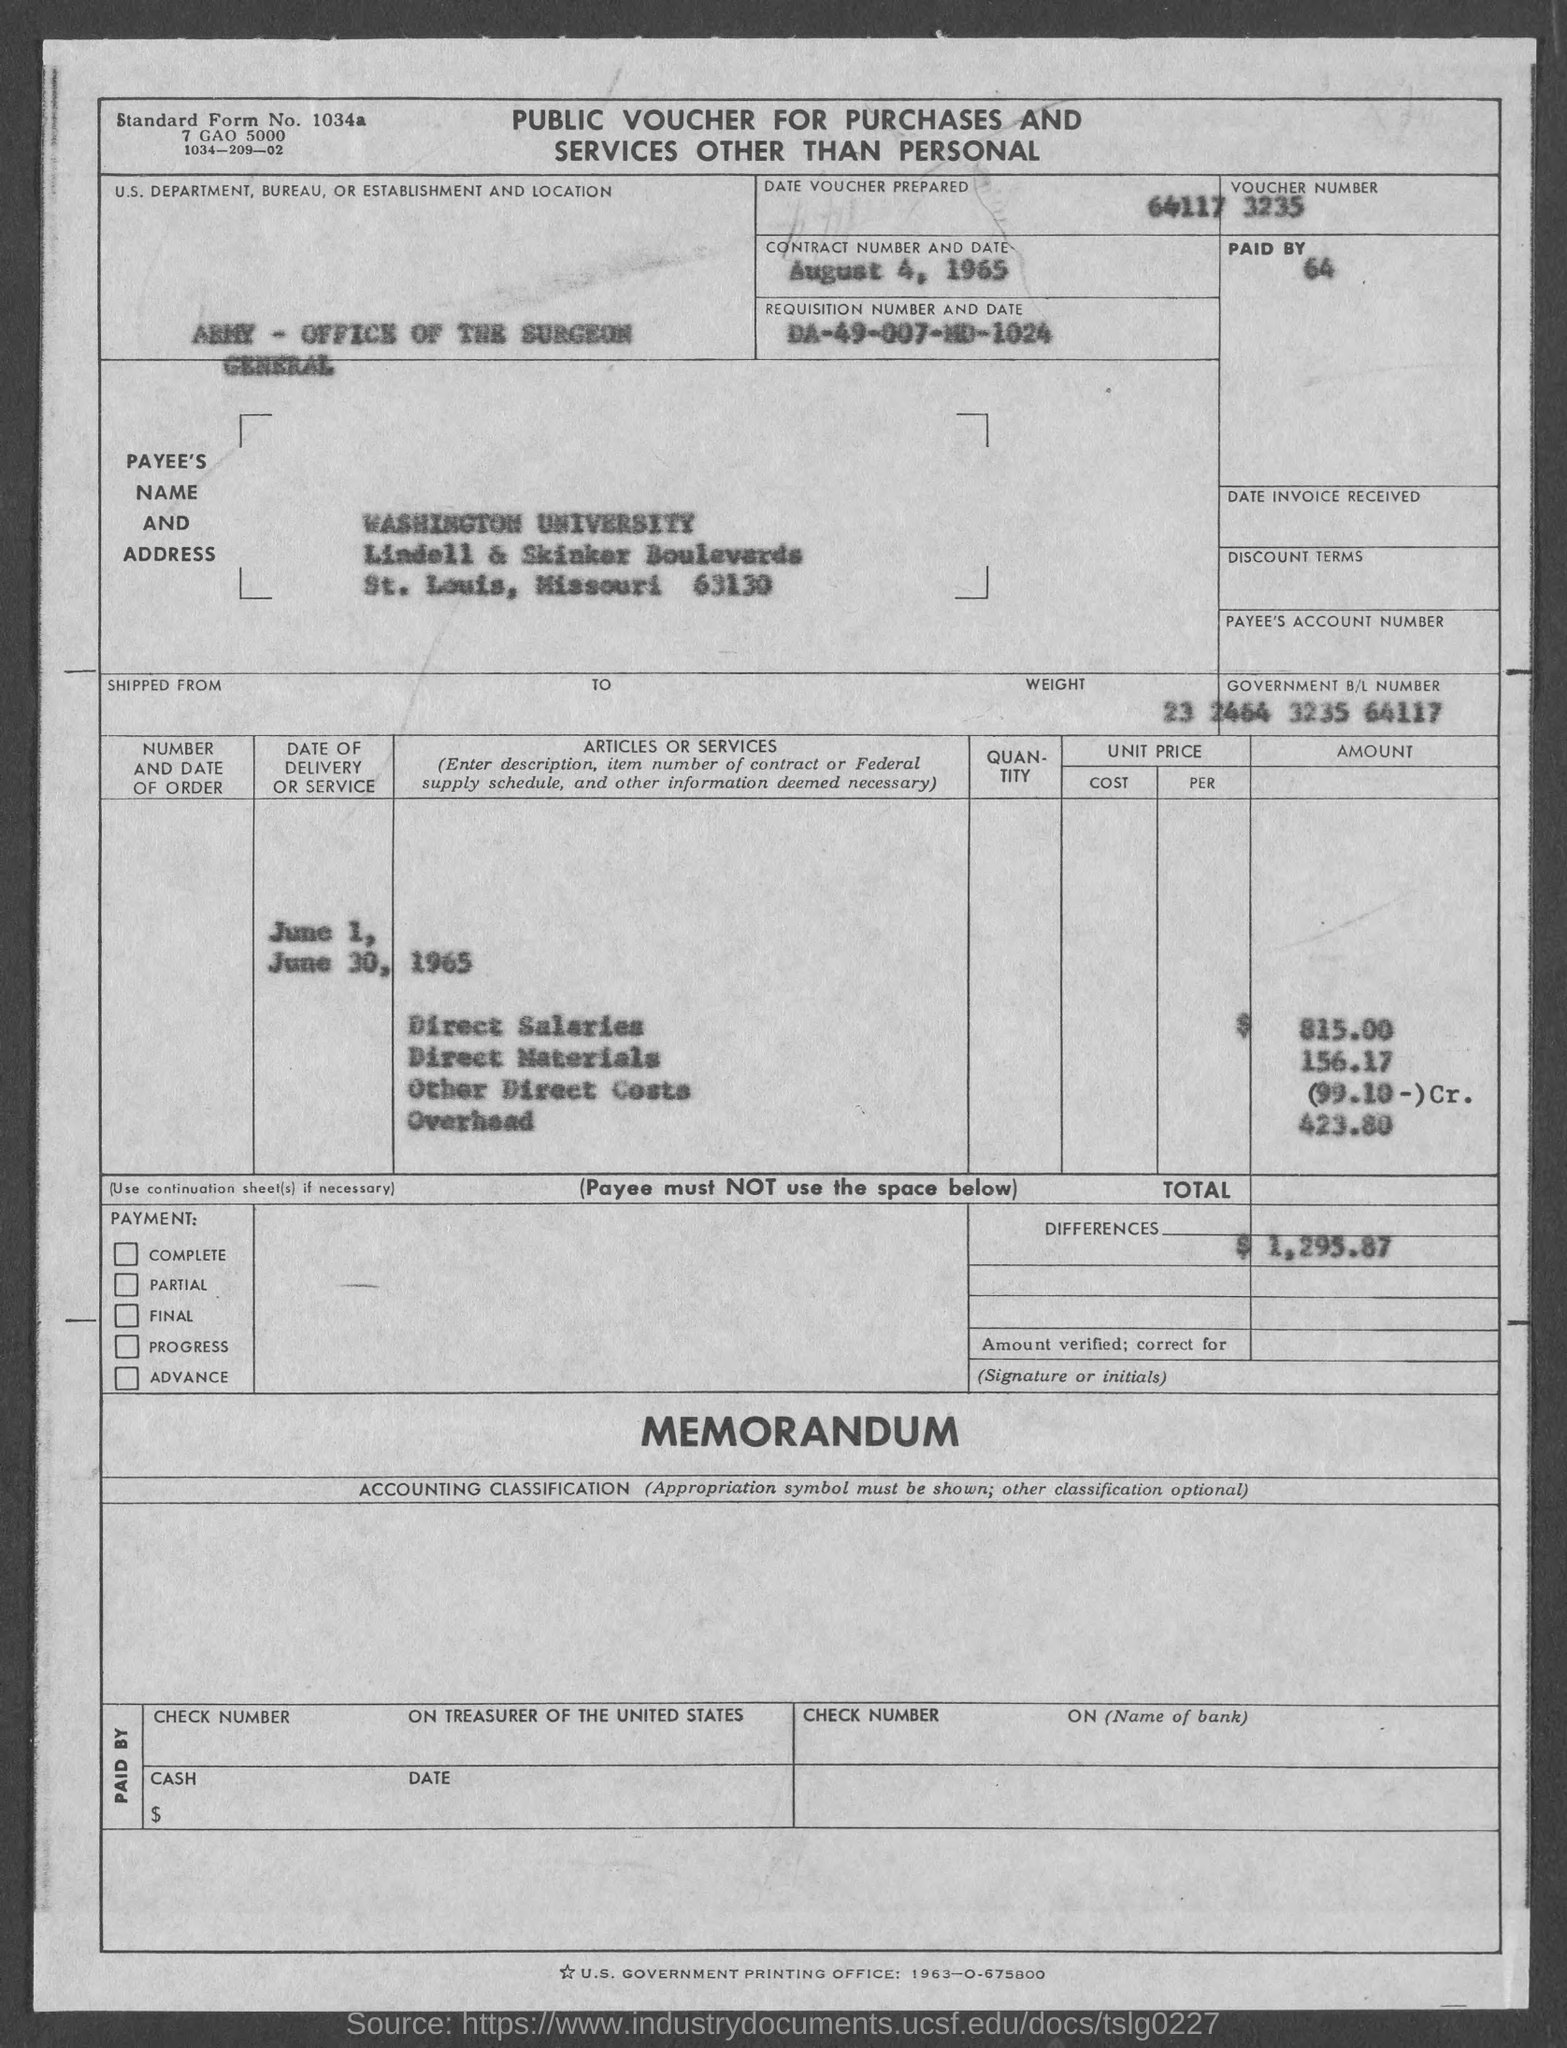Outline some significant characteristics in this image. The amount for direct materials as mentioned in the given form is 156.17. I'm sorry, but I don't see a form or any context that mentions the amount of overhead. Could you please provide more information or clarify your question? The amount of direct salaries mentioned in the given form is 815.00. The given page mentions the "army - office of the surgeon general" as a department, bureau, or establishment. The requisition number and date mentioned on the given page are DA-49-007-MD-1024. 